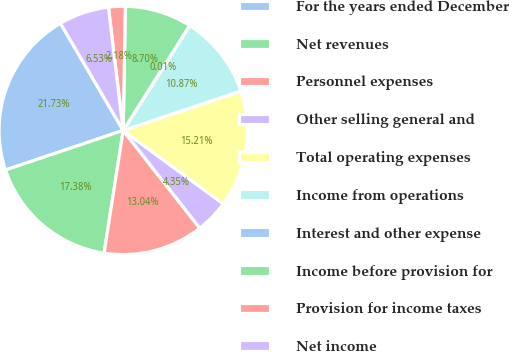<chart> <loc_0><loc_0><loc_500><loc_500><pie_chart><fcel>For the years ended December<fcel>Net revenues<fcel>Personnel expenses<fcel>Other selling general and<fcel>Total operating expenses<fcel>Income from operations<fcel>Interest and other expense<fcel>Income before provision for<fcel>Provision for income taxes<fcel>Net income<nl><fcel>21.73%<fcel>17.38%<fcel>13.04%<fcel>4.35%<fcel>15.21%<fcel>10.87%<fcel>0.01%<fcel>8.7%<fcel>2.18%<fcel>6.53%<nl></chart> 